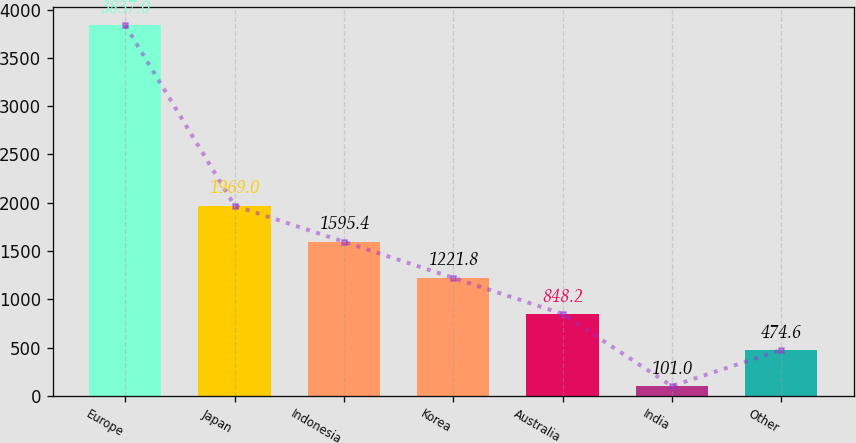Convert chart. <chart><loc_0><loc_0><loc_500><loc_500><bar_chart><fcel>Europe<fcel>Japan<fcel>Indonesia<fcel>Korea<fcel>Australia<fcel>India<fcel>Other<nl><fcel>3837<fcel>1969<fcel>1595.4<fcel>1221.8<fcel>848.2<fcel>101<fcel>474.6<nl></chart> 